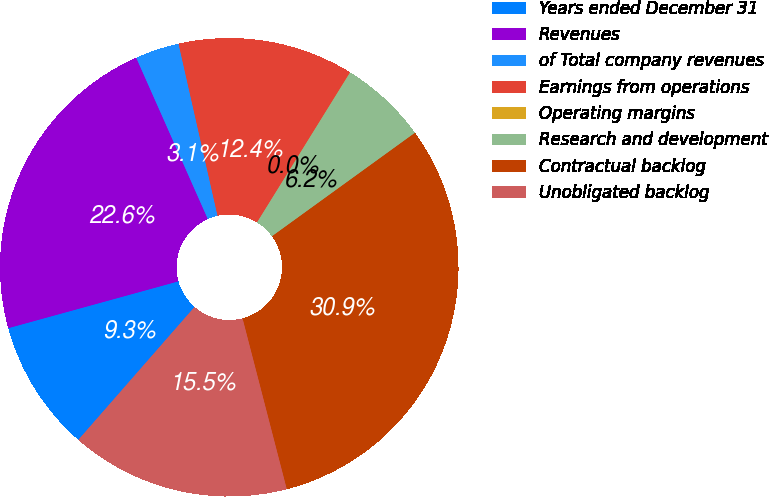Convert chart. <chart><loc_0><loc_0><loc_500><loc_500><pie_chart><fcel>Years ended December 31<fcel>Revenues<fcel>of Total company revenues<fcel>Earnings from operations<fcel>Operating margins<fcel>Research and development<fcel>Contractual backlog<fcel>Unobligated backlog<nl><fcel>9.29%<fcel>22.63%<fcel>3.1%<fcel>12.38%<fcel>0.01%<fcel>6.19%<fcel>30.94%<fcel>15.47%<nl></chart> 